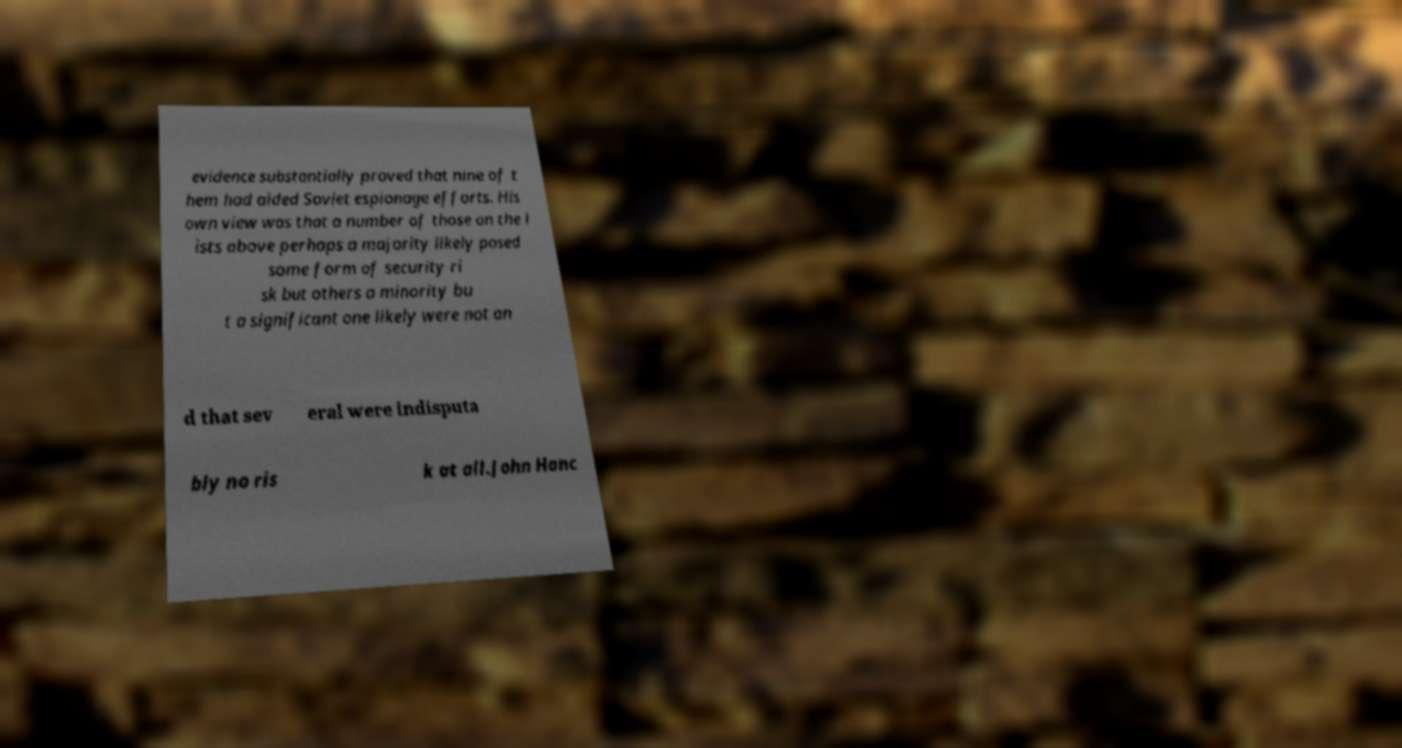Can you accurately transcribe the text from the provided image for me? evidence substantially proved that nine of t hem had aided Soviet espionage efforts. His own view was that a number of those on the l ists above perhaps a majority likely posed some form of security ri sk but others a minority bu t a significant one likely were not an d that sev eral were indisputa bly no ris k at all.John Hanc 